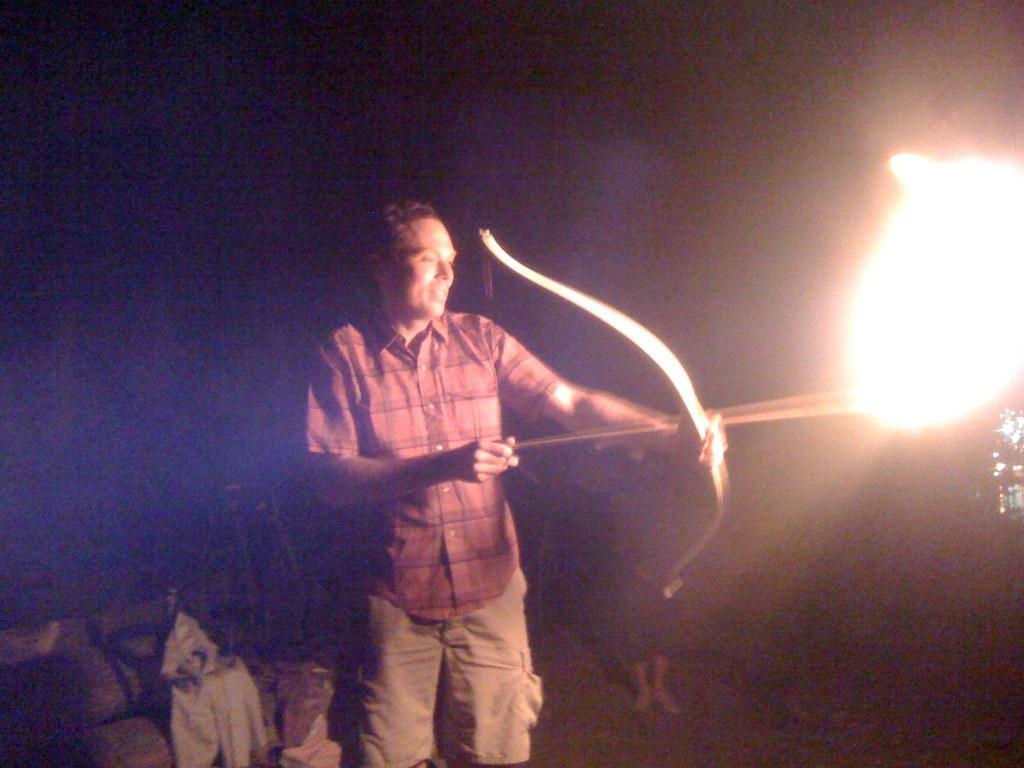Please provide a concise description of this image. In this image I can see the dark picture in which I can see a person is standing and holding an arrow and a bow in his hand. I can see fire to the right side of the image. I can see the dark background. 